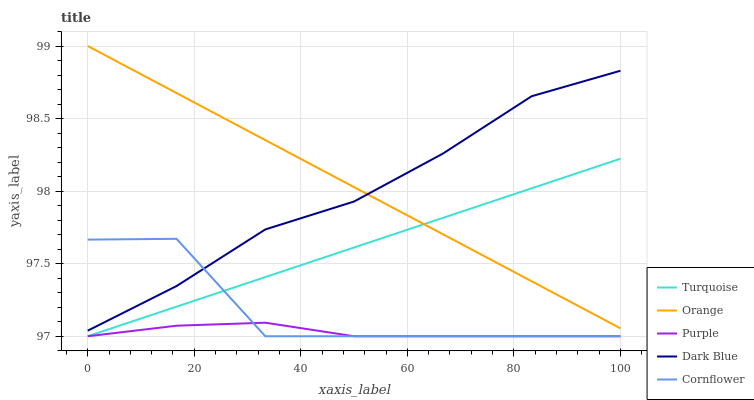Does Purple have the minimum area under the curve?
Answer yes or no. Yes. Does Orange have the maximum area under the curve?
Answer yes or no. Yes. Does Turquoise have the minimum area under the curve?
Answer yes or no. No. Does Turquoise have the maximum area under the curve?
Answer yes or no. No. Is Orange the smoothest?
Answer yes or no. Yes. Is Cornflower the roughest?
Answer yes or no. Yes. Is Purple the smoothest?
Answer yes or no. No. Is Purple the roughest?
Answer yes or no. No. Does Dark Blue have the lowest value?
Answer yes or no. No. Does Turquoise have the highest value?
Answer yes or no. No. Is Purple less than Orange?
Answer yes or no. Yes. Is Orange greater than Cornflower?
Answer yes or no. Yes. Does Purple intersect Orange?
Answer yes or no. No. 